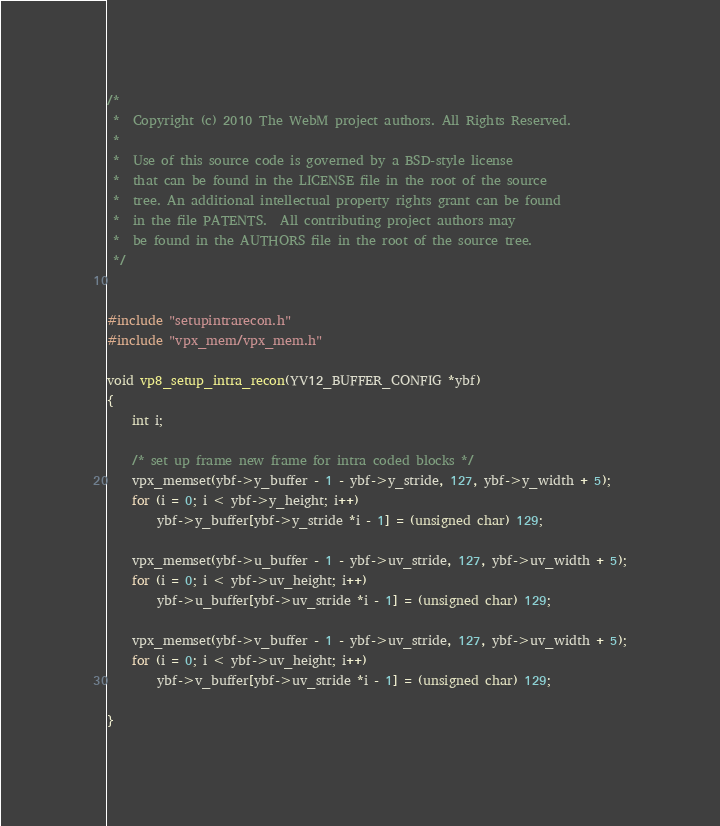Convert code to text. <code><loc_0><loc_0><loc_500><loc_500><_C_>/*
 *  Copyright (c) 2010 The WebM project authors. All Rights Reserved.
 *
 *  Use of this source code is governed by a BSD-style license
 *  that can be found in the LICENSE file in the root of the source
 *  tree. An additional intellectual property rights grant can be found
 *  in the file PATENTS.  All contributing project authors may
 *  be found in the AUTHORS file in the root of the source tree.
 */


#include "setupintrarecon.h"
#include "vpx_mem/vpx_mem.h"

void vp8_setup_intra_recon(YV12_BUFFER_CONFIG *ybf)
{
    int i;

    /* set up frame new frame for intra coded blocks */
    vpx_memset(ybf->y_buffer - 1 - ybf->y_stride, 127, ybf->y_width + 5);
    for (i = 0; i < ybf->y_height; i++)
        ybf->y_buffer[ybf->y_stride *i - 1] = (unsigned char) 129;

    vpx_memset(ybf->u_buffer - 1 - ybf->uv_stride, 127, ybf->uv_width + 5);
    for (i = 0; i < ybf->uv_height; i++)
        ybf->u_buffer[ybf->uv_stride *i - 1] = (unsigned char) 129;

    vpx_memset(ybf->v_buffer - 1 - ybf->uv_stride, 127, ybf->uv_width + 5);
    for (i = 0; i < ybf->uv_height; i++)
        ybf->v_buffer[ybf->uv_stride *i - 1] = (unsigned char) 129;

}
</code> 